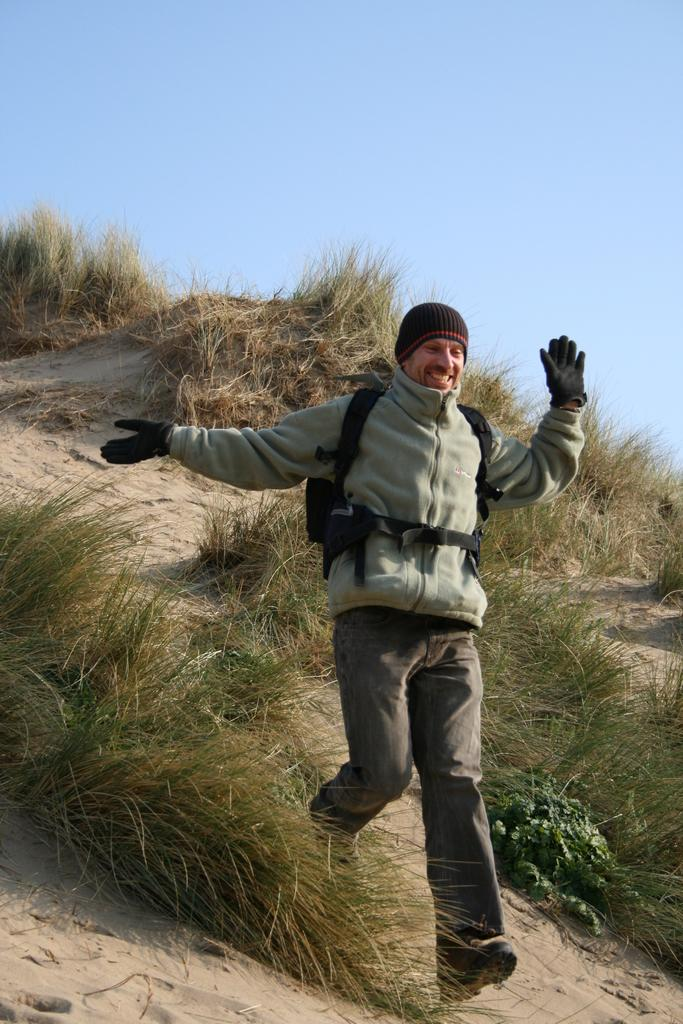What is the person in the image doing? The person is running in the image. Where is the person running? The person is running on a hill. What type of vegetation can be seen in the image? Shrubs are visible in the image. What is visible in the background of the image? The sky is visible in the image. What type of liquid is being blown by the person in the image? There is no liquid or blowing action present in the image; the person is simply running on a hill. 